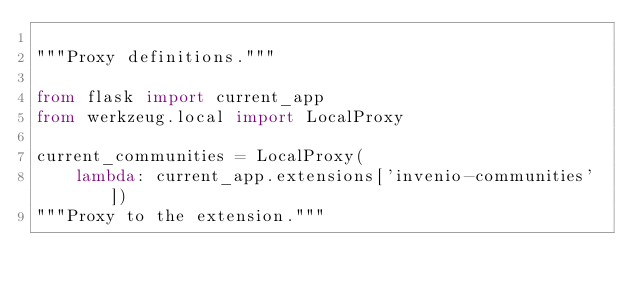<code> <loc_0><loc_0><loc_500><loc_500><_Python_>
"""Proxy definitions."""

from flask import current_app
from werkzeug.local import LocalProxy

current_communities = LocalProxy(
    lambda: current_app.extensions['invenio-communities'])
"""Proxy to the extension."""
</code> 